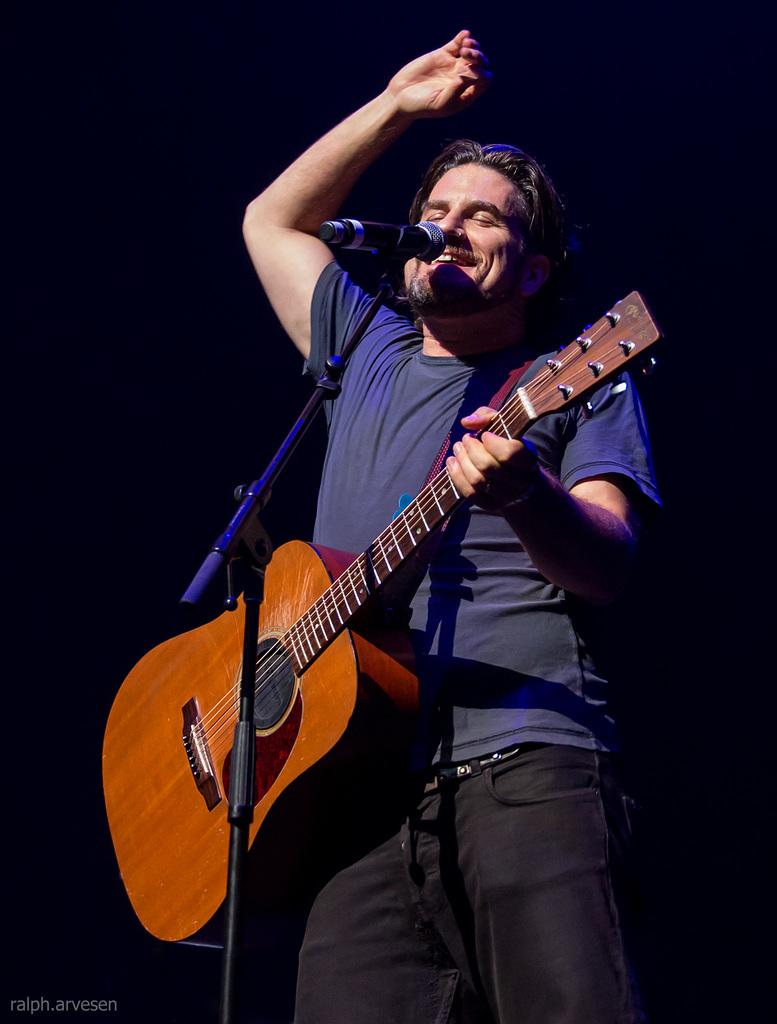What is the main subject of the image? The main subject of the image is a guy. What is the guy wearing in the image? The guy is wearing a blue shirt in the image. What activity is the guy engaged in? The guy is playing a guitar and singing in the image. What object is in front of the guy? There is a microphone in front of the guy in the image. What color is the background of the image? The background of the image is black. What type of plastic is the guy using to write his lyrics in the image? There is no plastic or writing activity present in the image. 